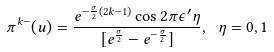<formula> <loc_0><loc_0><loc_500><loc_500>\pi ^ { k - } ( u ) = \frac { e ^ { - \frac { \sigma } { 2 } ( 2 k - 1 ) } \cos 2 \pi \epsilon ^ { \prime } \eta } { [ e ^ { \frac { \sigma } { 2 } } - e ^ { - \frac { \sigma } { 2 } } ] } , \ \eta = 0 , 1</formula> 